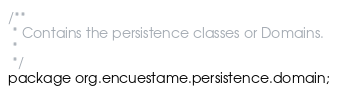<code> <loc_0><loc_0><loc_500><loc_500><_Java_>/**
 * Contains the persistence classes or Domains.
 *
 */
package org.encuestame.persistence.domain;</code> 